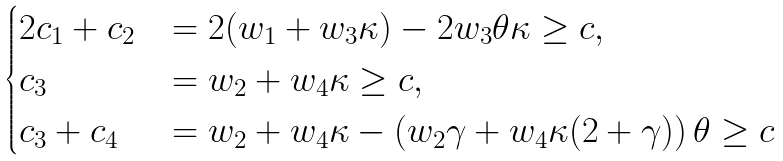Convert formula to latex. <formula><loc_0><loc_0><loc_500><loc_500>\begin{cases} 2 c _ { 1 } + c _ { 2 } & = 2 ( w _ { 1 } + w _ { 3 } \kappa ) - 2 w _ { 3 } \theta \kappa \geq c , \\ c _ { 3 } & = w _ { 2 } + w _ { 4 } \kappa \geq c , \\ c _ { 3 } + c _ { 4 } & = w _ { 2 } + w _ { 4 } \kappa - \left ( w _ { 2 } \gamma + w _ { 4 } \kappa ( 2 + \gamma ) \right ) \theta \geq c \end{cases}</formula> 